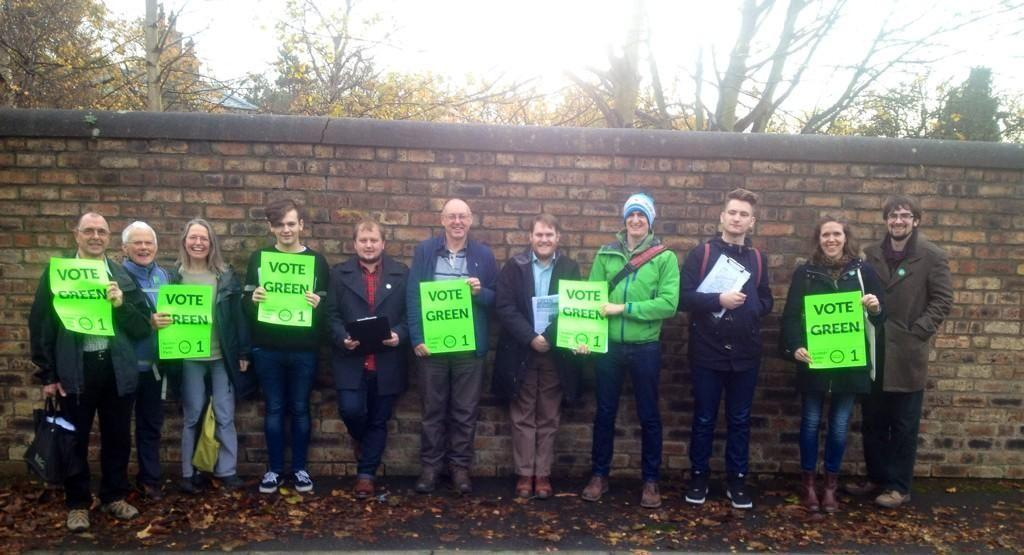What are the people in the image doing? The people in the image are standing on the ground. What are the people holding in the image? The people are holding posters with text. Can you describe any objects visible in the image? There are objects visible in the image, but their specific nature is not mentioned in the facts. What can be seen in the background of the image? In the background, there is a wall, trees, and the sky. What type of peace can be seen in the image? There is no reference to peace in the image, so it cannot be determined from the facts. What is the condition of the head of the person holding the poster? The facts do not mention the condition of the person's head, so it cannot be determined from the image. 